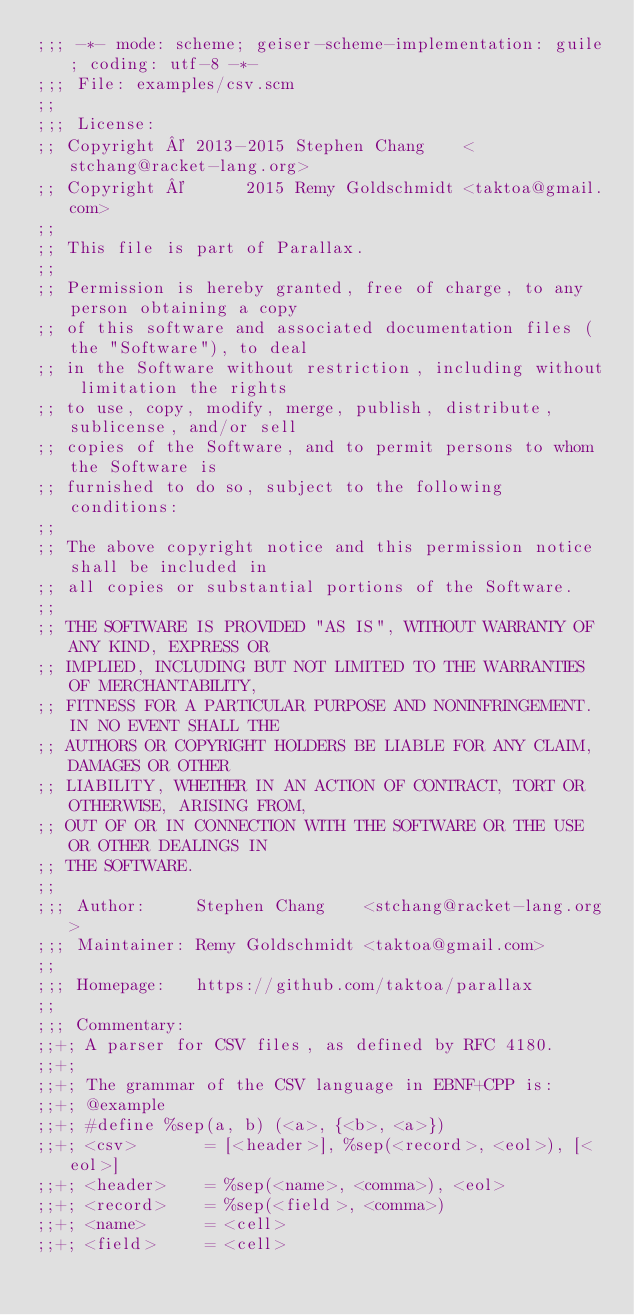Convert code to text. <code><loc_0><loc_0><loc_500><loc_500><_Scheme_>;;; -*- mode: scheme; geiser-scheme-implementation: guile; coding: utf-8 -*-
;;; File: examples/csv.scm
;;
;;; License:
;; Copyright © 2013-2015 Stephen Chang    <stchang@racket-lang.org>
;; Copyright ©      2015 Remy Goldschmidt <taktoa@gmail.com>
;;
;; This file is part of Parallax.
;;
;; Permission is hereby granted, free of charge, to any person obtaining a copy
;; of this software and associated documentation files (the "Software"), to deal
;; in the Software without restriction, including without limitation the rights
;; to use, copy, modify, merge, publish, distribute, sublicense, and/or sell
;; copies of the Software, and to permit persons to whom the Software is
;; furnished to do so, subject to the following conditions:
;;
;; The above copyright notice and this permission notice shall be included in
;; all copies or substantial portions of the Software.
;;
;; THE SOFTWARE IS PROVIDED "AS IS", WITHOUT WARRANTY OF ANY KIND, EXPRESS OR
;; IMPLIED, INCLUDING BUT NOT LIMITED TO THE WARRANTIES OF MERCHANTABILITY,
;; FITNESS FOR A PARTICULAR PURPOSE AND NONINFRINGEMENT. IN NO EVENT SHALL THE
;; AUTHORS OR COPYRIGHT HOLDERS BE LIABLE FOR ANY CLAIM, DAMAGES OR OTHER
;; LIABILITY, WHETHER IN AN ACTION OF CONTRACT, TORT OR OTHERWISE, ARISING FROM,
;; OUT OF OR IN CONNECTION WITH THE SOFTWARE OR THE USE OR OTHER DEALINGS IN
;; THE SOFTWARE.
;;
;;; Author:     Stephen Chang    <stchang@racket-lang.org>
;;; Maintainer: Remy Goldschmidt <taktoa@gmail.com>
;;
;;; Homepage:   https://github.com/taktoa/parallax
;;
;;; Commentary:
;;+; A parser for CSV files, as defined by RFC 4180.
;;+;
;;+; The grammar of the CSV language in EBNF+CPP is:
;;+; @example
;;+; #define %sep(a, b) (<a>, {<b>, <a>})
;;+; <csv>       = [<header>], %sep(<record>, <eol>), [<eol>]
;;+; <header>    = %sep(<name>, <comma>), <eol>
;;+; <record>    = %sep(<field>, <comma>)
;;+; <name>      = <cell>
;;+; <field>     = <cell></code> 